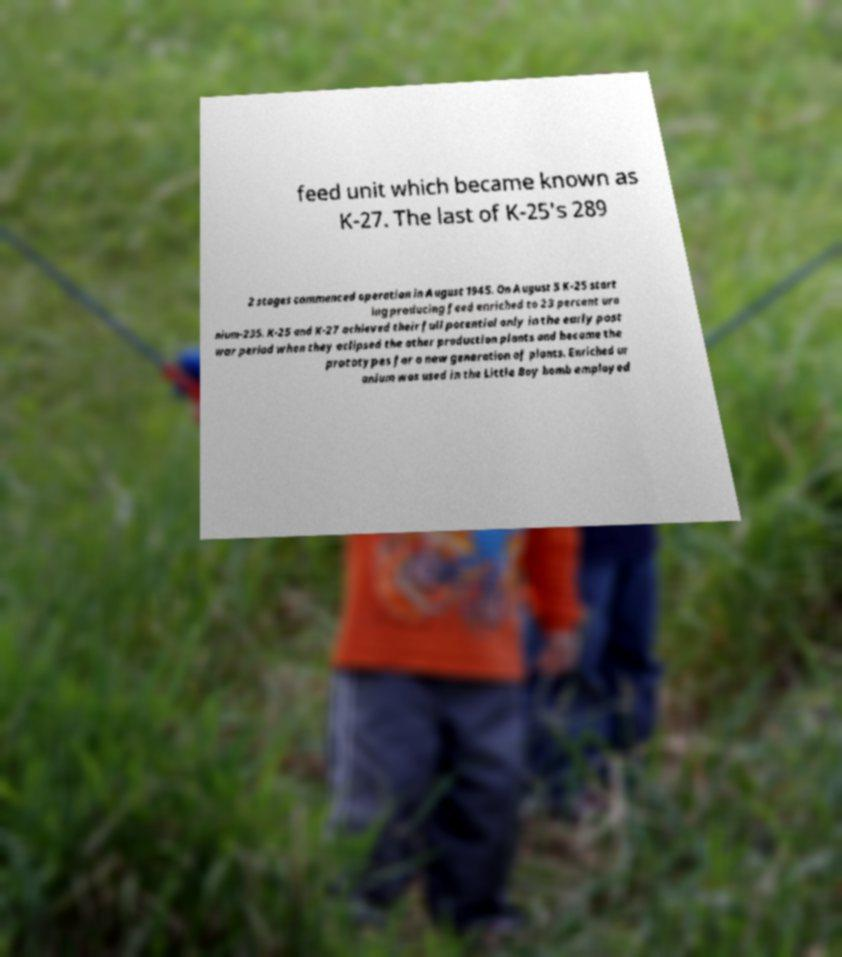Could you assist in decoding the text presented in this image and type it out clearly? feed unit which became known as K-27. The last of K-25's 289 2 stages commenced operation in August 1945. On August 5 K-25 start ing producing feed enriched to 23 percent ura nium-235. K-25 and K-27 achieved their full potential only in the early post war period when they eclipsed the other production plants and became the prototypes for a new generation of plants. Enriched ur anium was used in the Little Boy bomb employed 